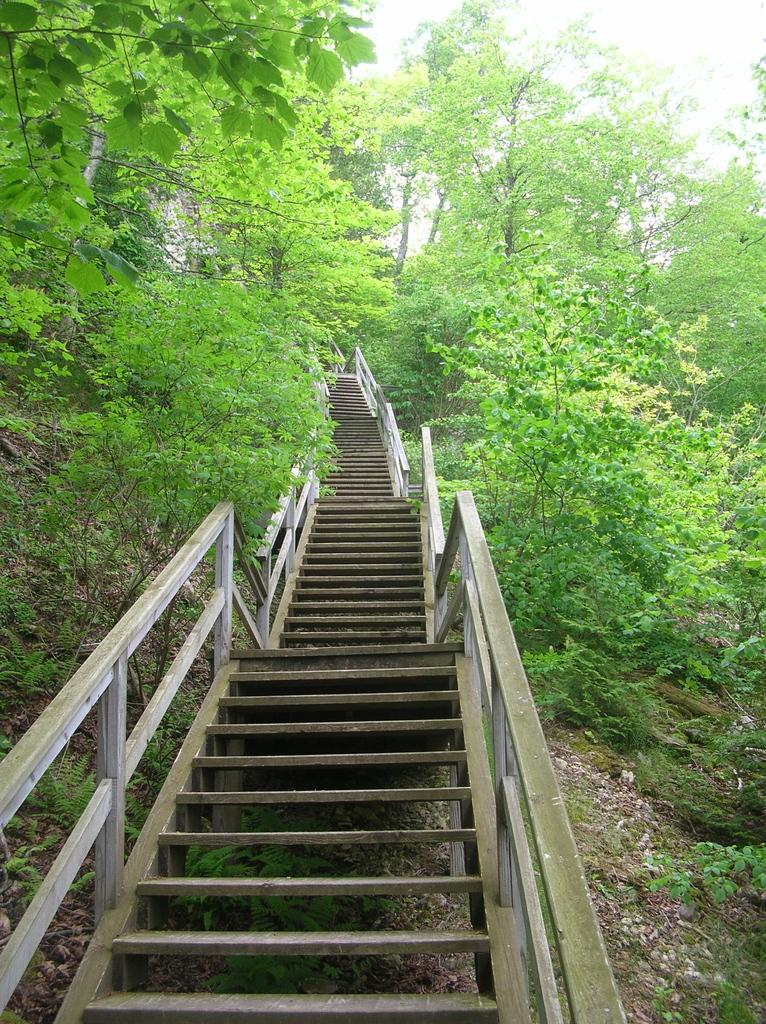What is located in the center of the image? There are stairs in the center of the image. What type of vegetation can be seen in the image? There are many trees in the image. What type of bell can be heard ringing in the image? There is no bell present in the image, and therefore no sound can be heard. 